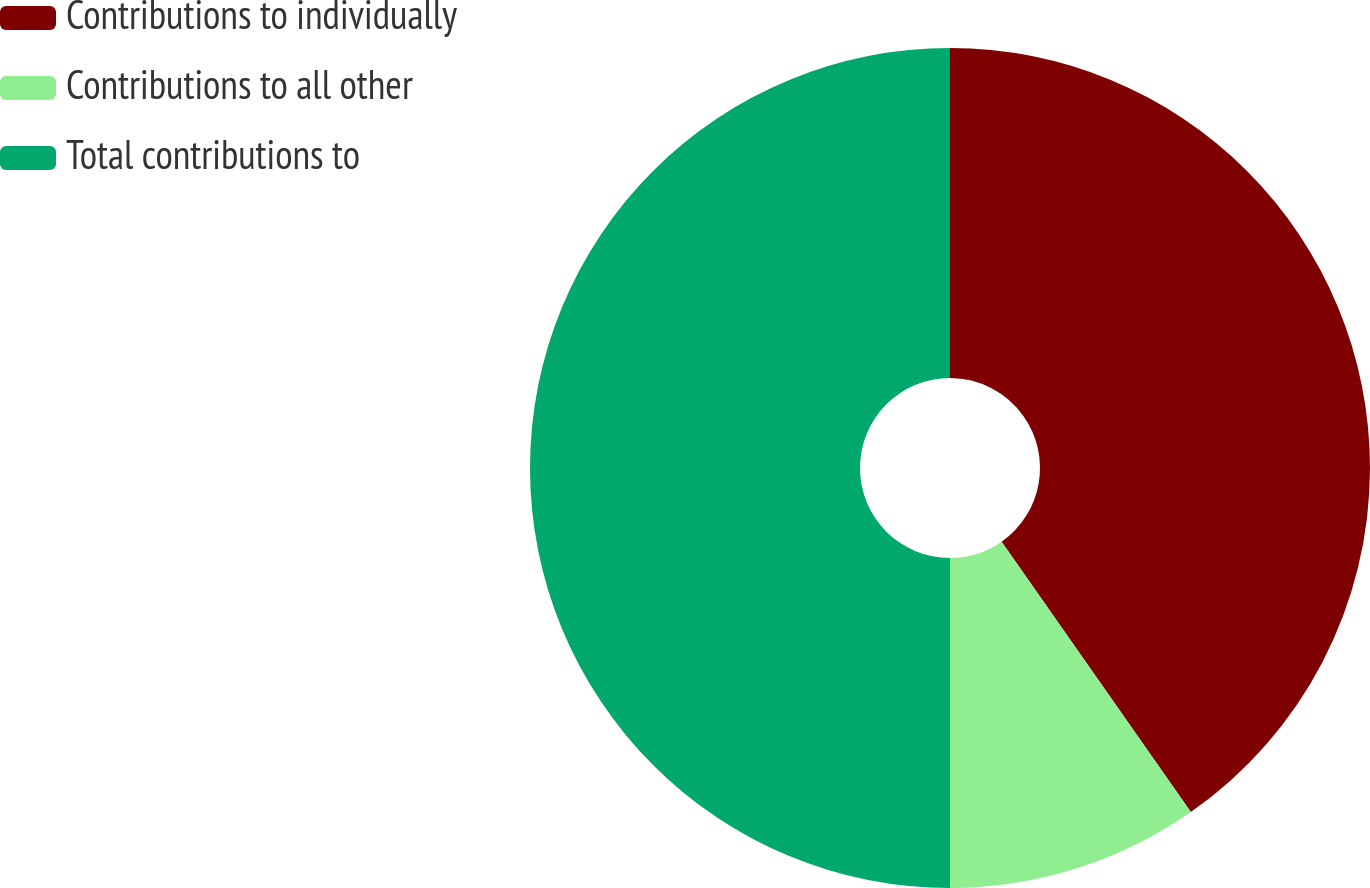Convert chart to OTSL. <chart><loc_0><loc_0><loc_500><loc_500><pie_chart><fcel>Contributions to individually<fcel>Contributions to all other<fcel>Total contributions to<nl><fcel>40.28%<fcel>9.72%<fcel>50.0%<nl></chart> 